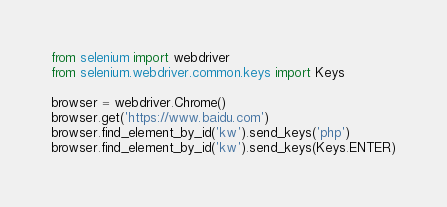Convert code to text. <code><loc_0><loc_0><loc_500><loc_500><_Python_>from selenium import webdriver
from selenium.webdriver.common.keys import Keys

browser = webdriver.Chrome()
browser.get('https://www.baidu.com')
browser.find_element_by_id('kw').send_keys('php')
browser.find_element_by_id('kw').send_keys(Keys.ENTER)
</code> 